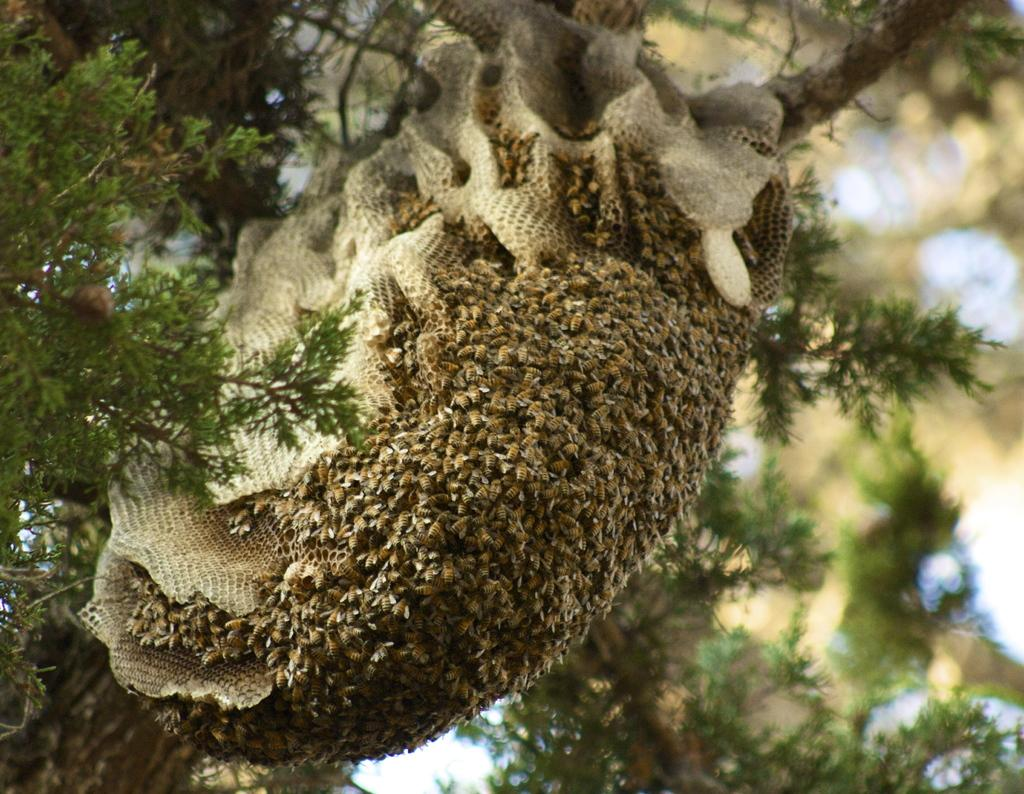What is located on a tree in the image? There is a honey bee hive on a tree in the image. How many honey bees can be seen in the image? There are many honey bees visible in the image. Where is the route that the kittens are following in the image? There are no kittens or routes present in the image. What letter is written on the honey bee hive in the image? There is no letter written on the honey bee hive in the image. 